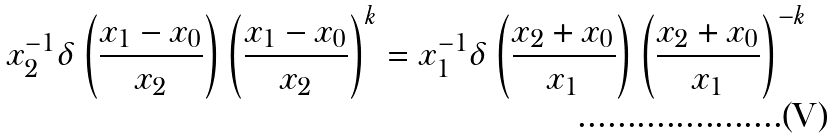<formula> <loc_0><loc_0><loc_500><loc_500>x _ { 2 } ^ { - 1 } \delta \left ( \frac { x _ { 1 } - x _ { 0 } } { x _ { 2 } } \right ) \left ( \frac { x _ { 1 } - x _ { 0 } } { x _ { 2 } } \right ) ^ { k } = x _ { 1 } ^ { - 1 } \delta \left ( \frac { x _ { 2 } + x _ { 0 } } { x _ { 1 } } \right ) \left ( \frac { x _ { 2 } + x _ { 0 } } { x _ { 1 } } \right ) ^ { - k }</formula> 